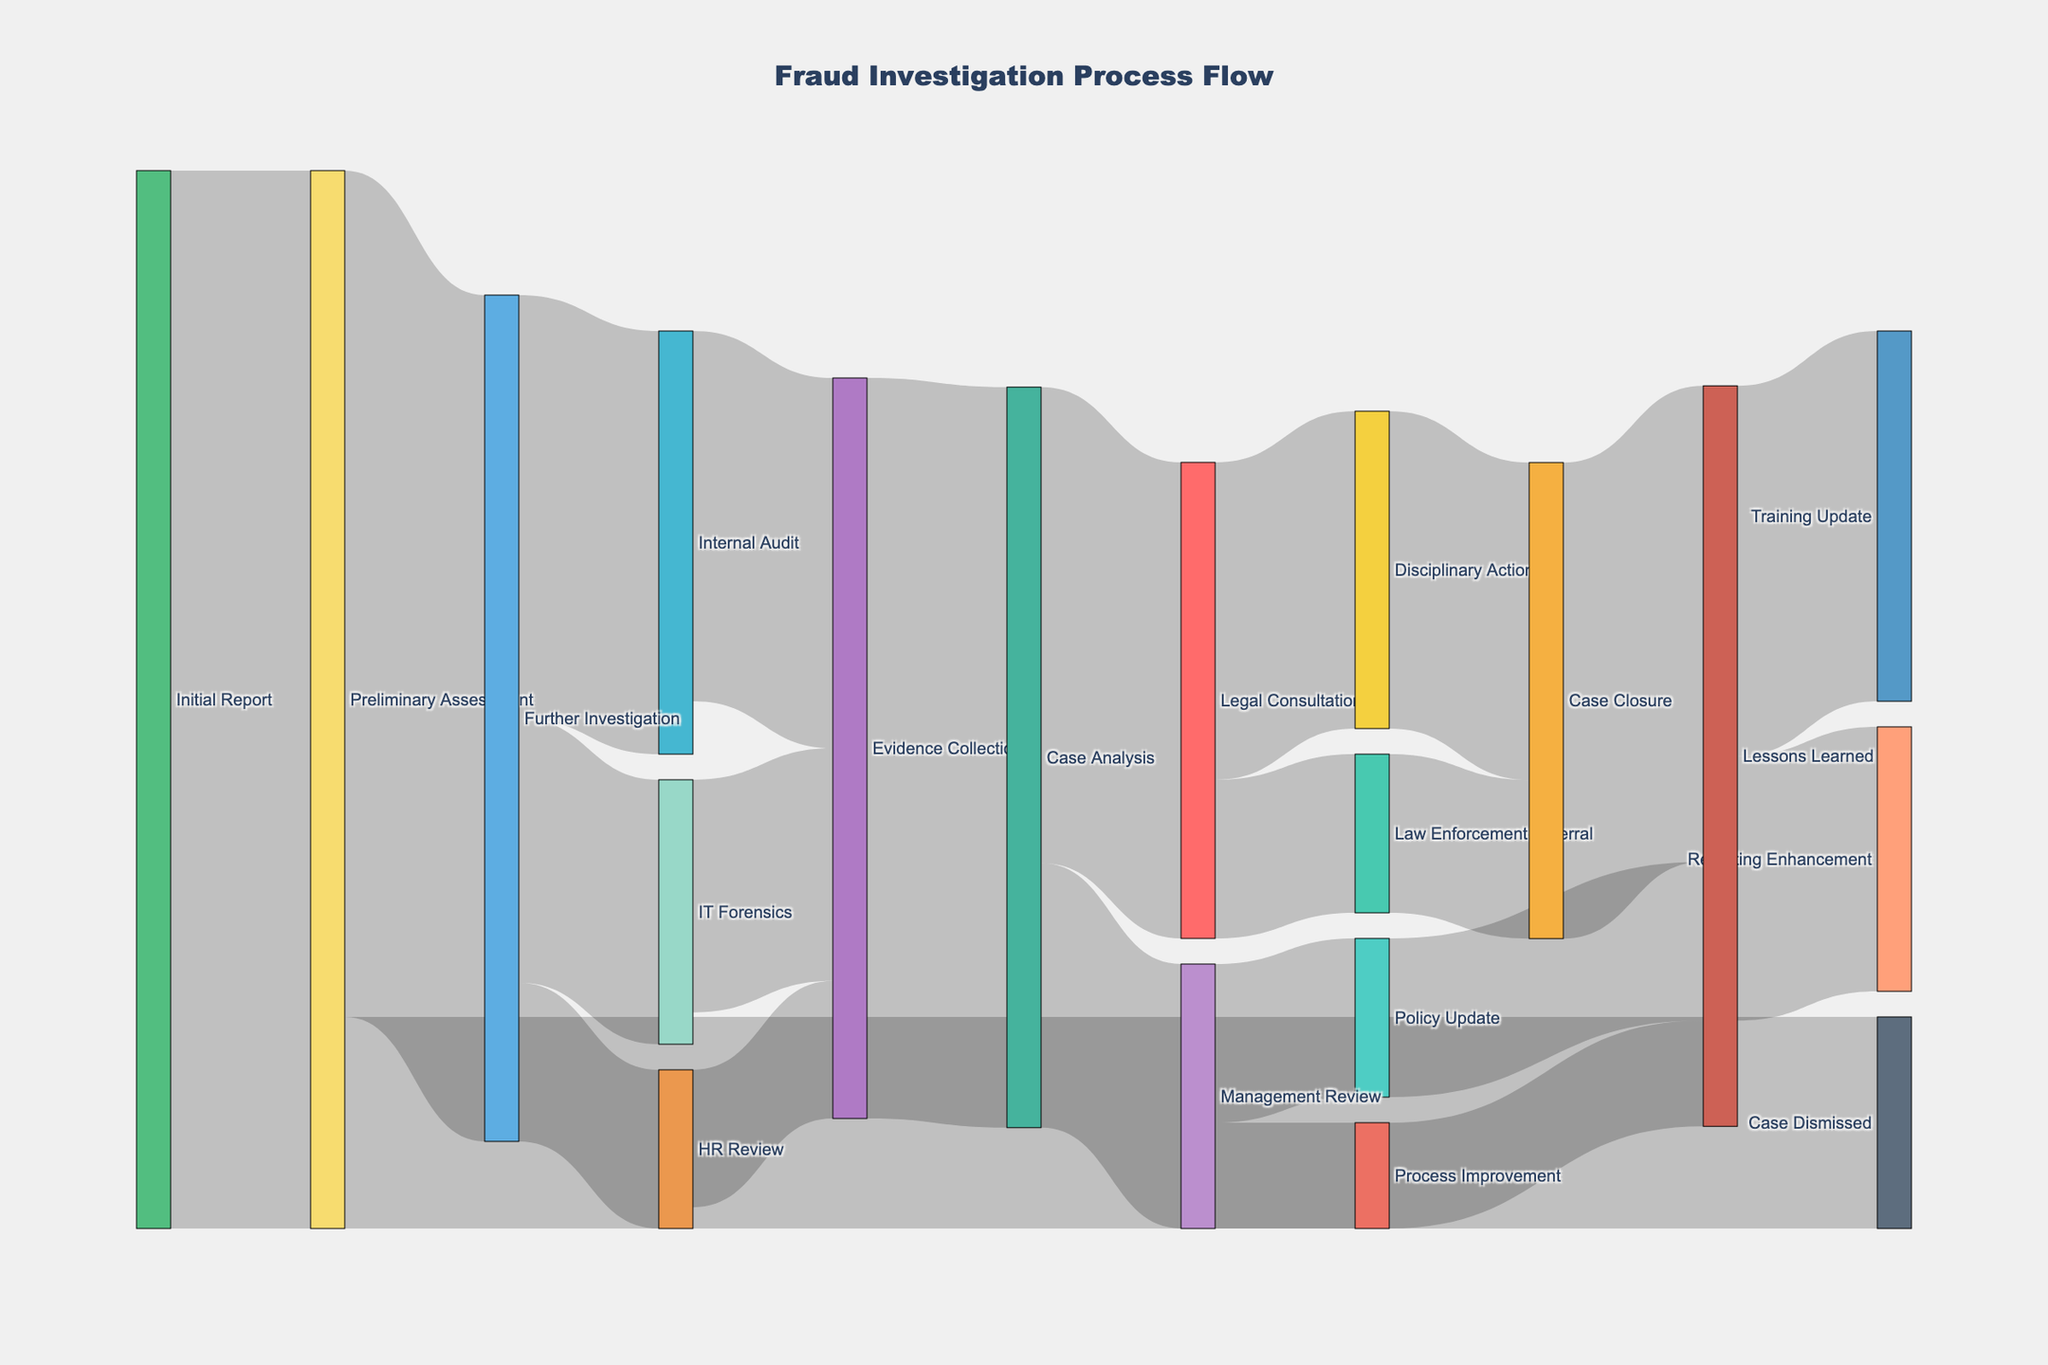How many initial reports lead to a preliminary assessment? The Sankey diagram shows a connection from 'Initial Report' to 'Preliminary Assessment' with a value of 100.
Answer: 100 Which phase has the highest value flowing into 'Evidence Collection'? 'Evidence Collection' receives flows from 'Internal Audit' (35), 'IT Forensics' (22), and 'HR Review' (13). The highest value is from 'Internal Audit'.
Answer: Internal Audit What is the total value that proceeds from 'Further Investigation'? The values flowing from 'Further Investigation' are to 'Internal Audit' (40), 'IT Forensics' (25), and 'HR Review' (15). Summing these values gives 40 + 25 + 15 = 80.
Answer: 80 How many cases proceed to 'Case Closure'? 'Case Closure' receives values from 'Disciplinary Action' (30) and 'Law Enforcement Referral' (15). Summing these gives 30 + 15 = 45.
Answer: 45 Which phase receives more cases, 'Case Analysis' or 'Lessons Learned'? 'Case Analysis' receives 70 cases from 'Evidence Collection'. 'Lessons Learned' receives 15 from 'Policy Update', 10 from 'Process Improvement', and 45 from 'Case Closure', which sums up to 70. Thus, both phases receive an equal amount.
Answer: Both receive 70 What’s the combined value entering 'Lessons Learned' from all previous stages? 'Lessons Learned' receives values from 'Case Closure' (45), 'Policy Update' (15), and 'Process Improvement' (10). Summing these values gives 45 + 15 + 10 = 70.
Answer: 70 Which pathway has the smallest flow value in the entire process? By examining the diagram, 'Further Investigation' to 'HR Review', and 'Management Review' to 'Process Improvement' both show the smallest flow value of 10.
Answer: Further Investigation to HR Review or Management Review to Process Improvement 